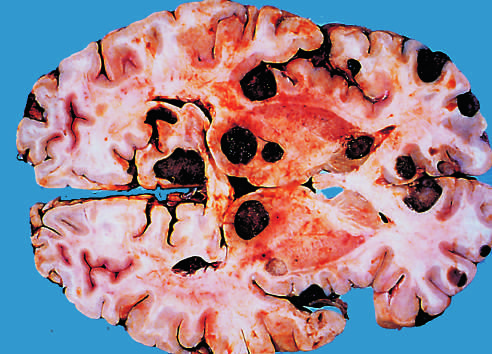tastatic lesions are distinguished grossly from most primary central nervous system tumors by whose multicentricity and well-demarcated margins?
Answer the question using a single word or phrase. Their 